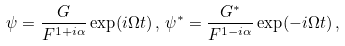Convert formula to latex. <formula><loc_0><loc_0><loc_500><loc_500>\psi = \frac { G } { F ^ { 1 + i \alpha } } \exp ( i \Omega t ) \, , \, \psi ^ { * } = \frac { G ^ { * } } { F ^ { 1 - i \alpha } } \exp ( - i \Omega t ) \, ,</formula> 